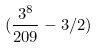<formula> <loc_0><loc_0><loc_500><loc_500>( \frac { 3 ^ { 8 } } { 2 0 9 } - 3 / 2 )</formula> 